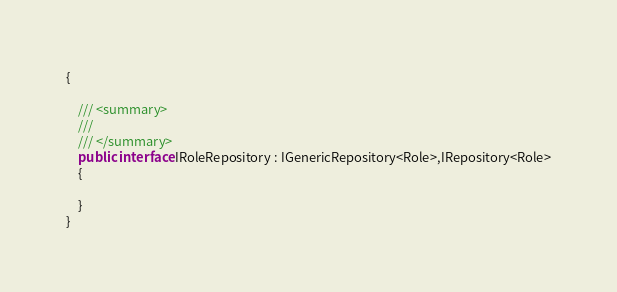Convert code to text. <code><loc_0><loc_0><loc_500><loc_500><_C#_>{

    /// <summary>
    /// 
    /// </summary>
    public interface IRoleRepository : IGenericRepository<Role>,IRepository<Role>
    {
            
    }
}
</code> 